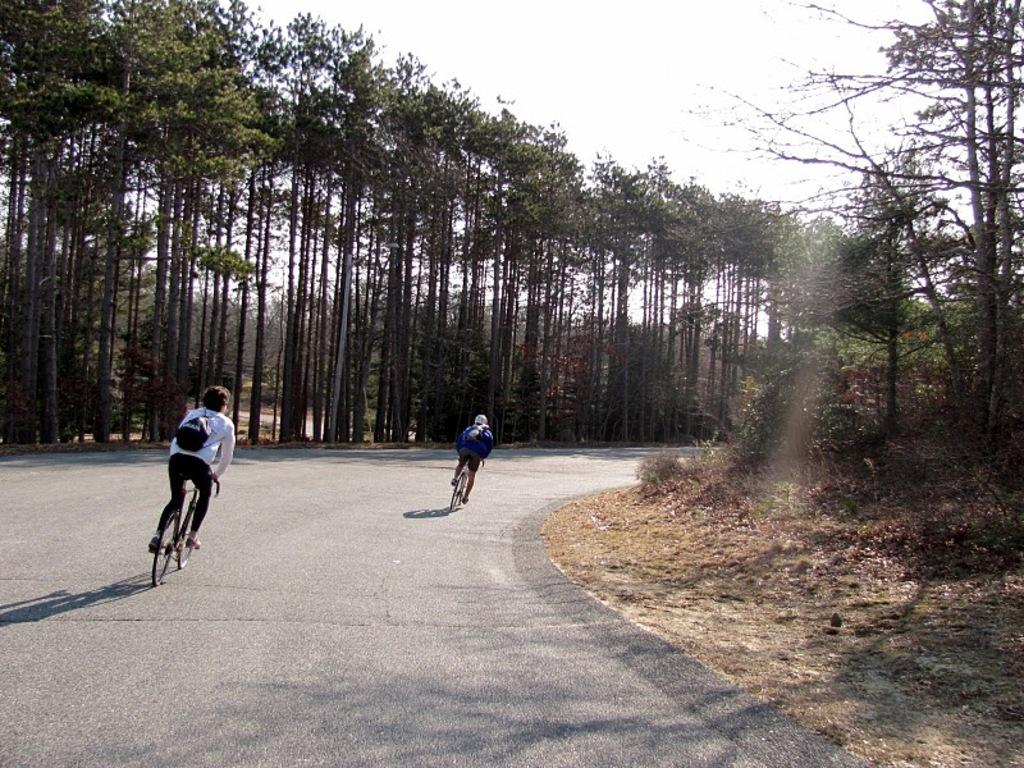Who or what is present in the image? There are people in the image. What are the people doing in the image? The people are riding bicycles. Where are the bicycles located in the image? The bicycles are on a road. What are the people carrying while riding their bicycles? The people are carrying backpacks. What can be seen in the background of the image? There are trees visible in the image. Where is the shelf located in the image? There is no shelf present in the image. Are there any fairies visible in the image? There are no fairies present in the image. 